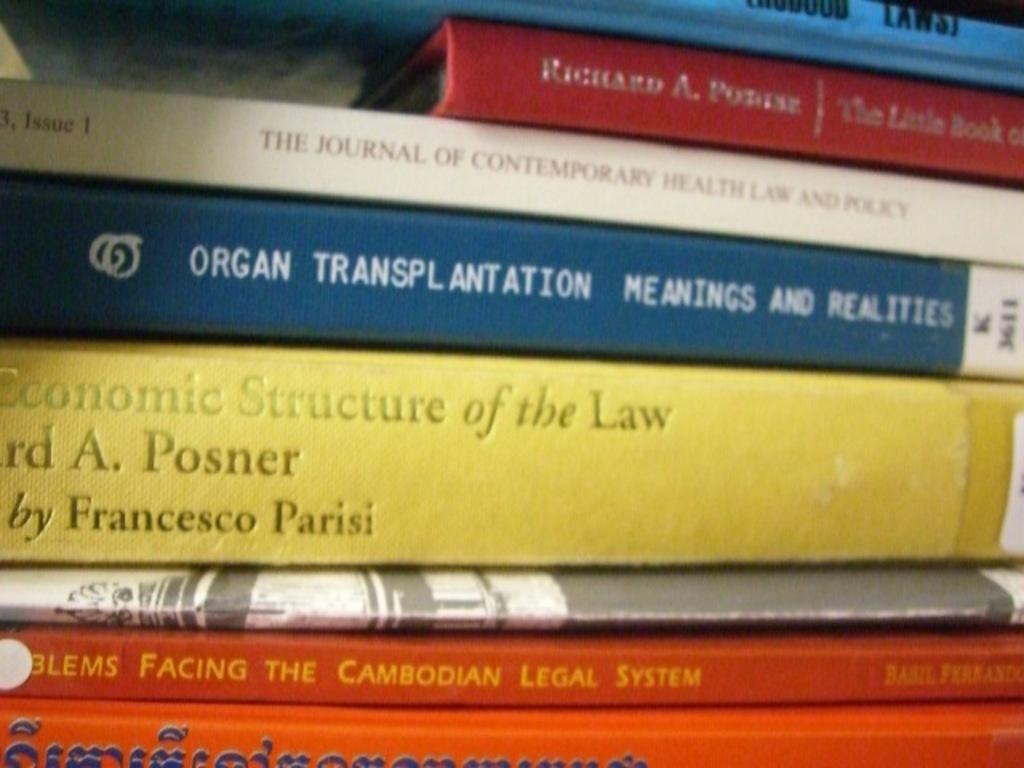<image>
Share a concise interpretation of the image provided. A stack of books includes one on organ transplantation. 